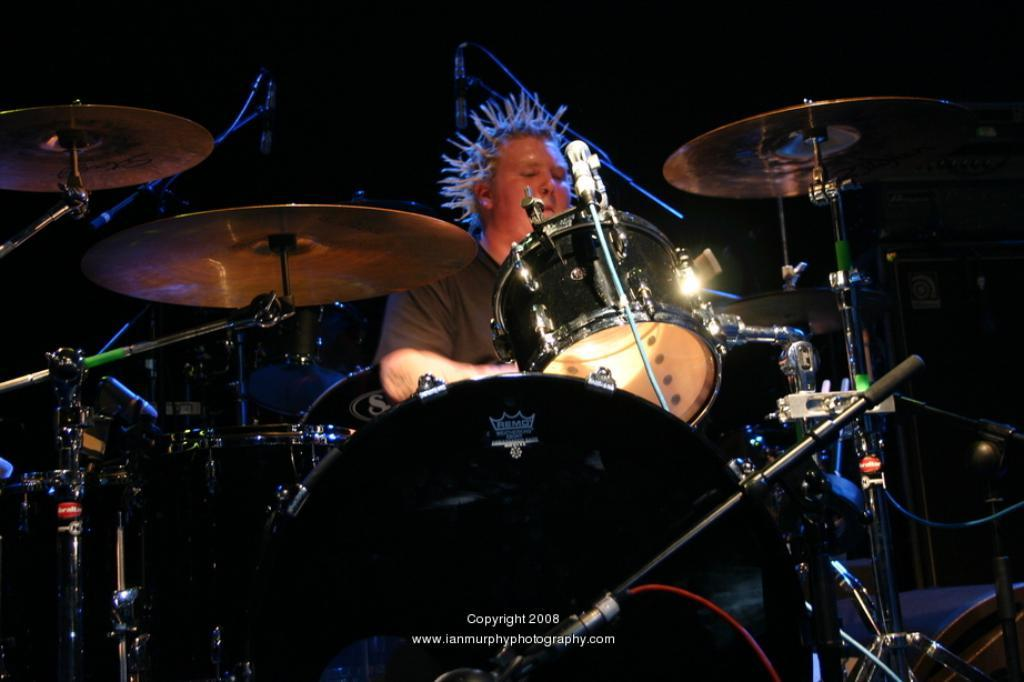Who or what can be seen in the image? There is a person visible in the image. What is the person doing or standing near in the image? The person is in front of musical instruments. Are there any additional details about the musical instruments? Yes, there is text on the musical instruments. How would you describe the overall setting or background of the image? The background of the image has a dark view. What type of alarm can be heard going off in the image? There is no alarm present or audible in the image. Is there a visitor visible in the image? The image only shows a person in front of musical instruments, and there is no mention of a visitor. 